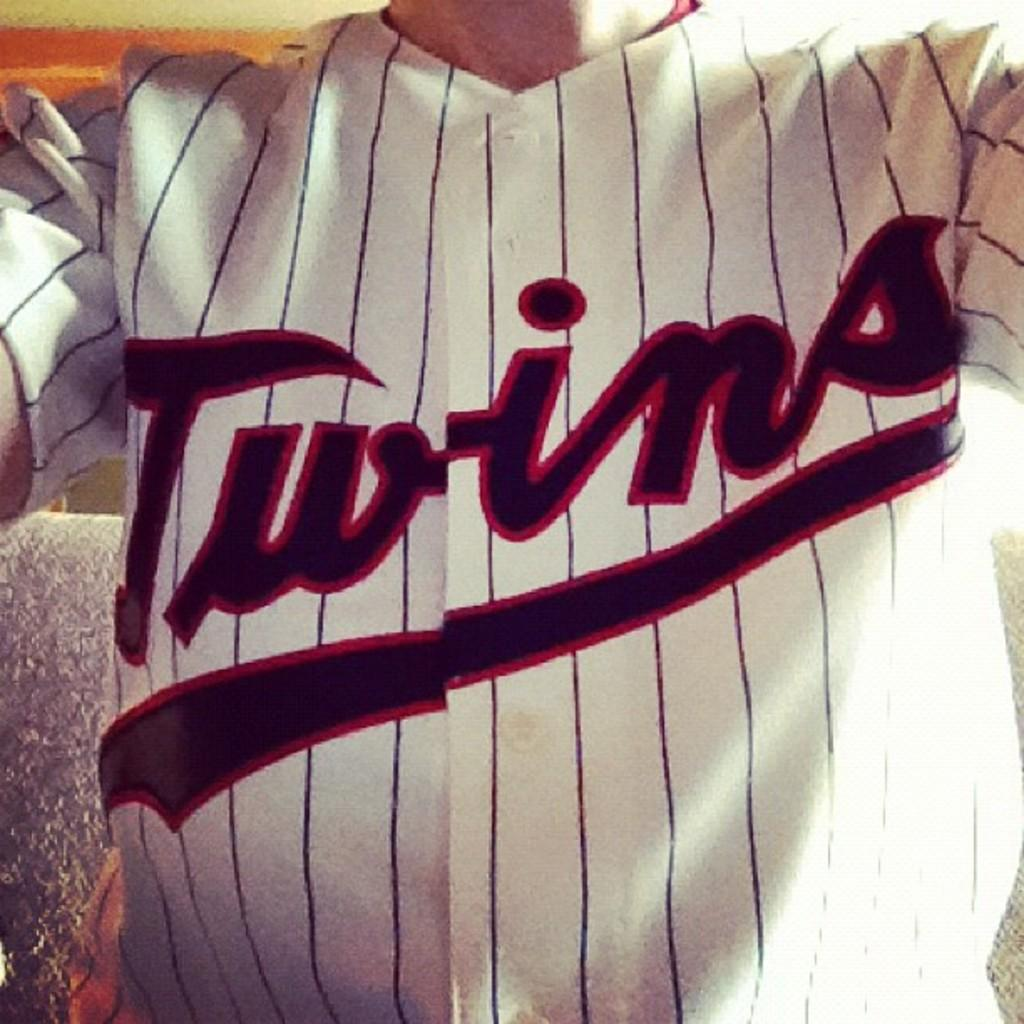<image>
Render a clear and concise summary of the photo. a jersey that has the word Twins on it 